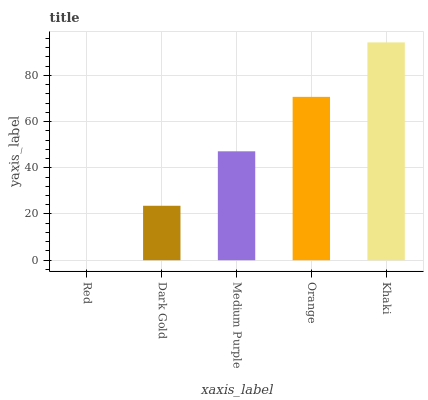Is Red the minimum?
Answer yes or no. Yes. Is Khaki the maximum?
Answer yes or no. Yes. Is Dark Gold the minimum?
Answer yes or no. No. Is Dark Gold the maximum?
Answer yes or no. No. Is Dark Gold greater than Red?
Answer yes or no. Yes. Is Red less than Dark Gold?
Answer yes or no. Yes. Is Red greater than Dark Gold?
Answer yes or no. No. Is Dark Gold less than Red?
Answer yes or no. No. Is Medium Purple the high median?
Answer yes or no. Yes. Is Medium Purple the low median?
Answer yes or no. Yes. Is Orange the high median?
Answer yes or no. No. Is Red the low median?
Answer yes or no. No. 